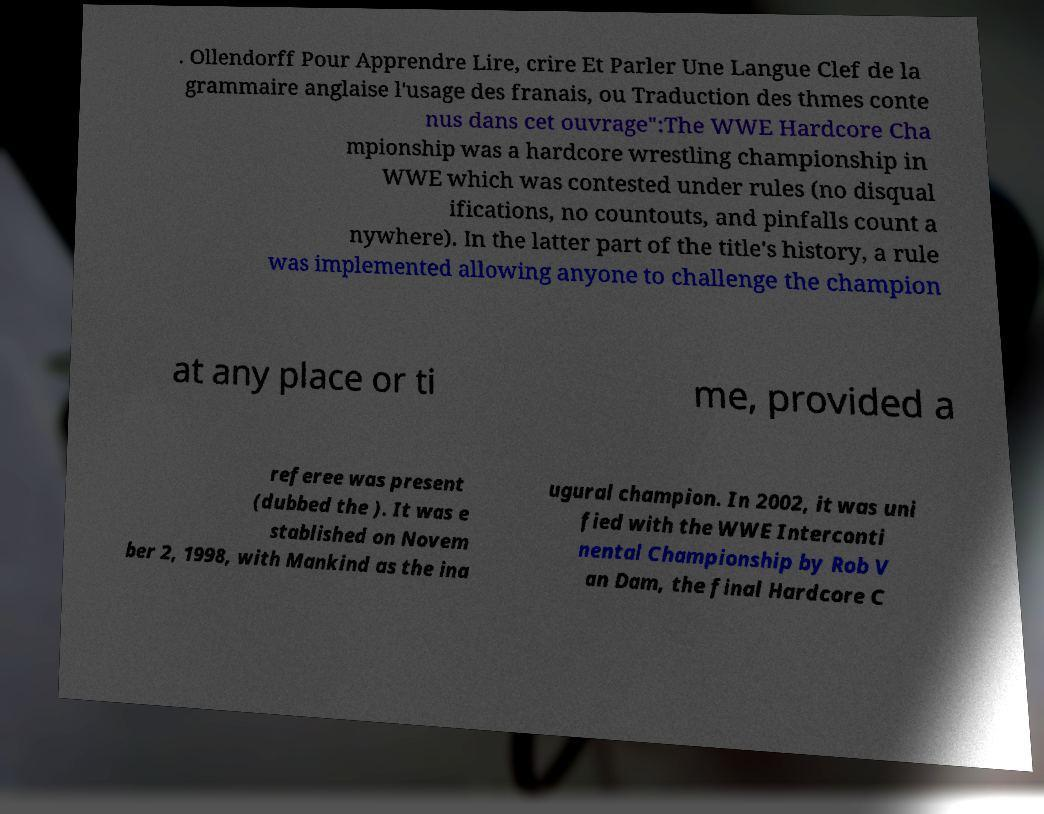Please read and relay the text visible in this image. What does it say? . Ollendorff Pour Apprendre Lire, crire Et Parler Une Langue Clef de la grammaire anglaise l'usage des franais, ou Traduction des thmes conte nus dans cet ouvrage":The WWE Hardcore Cha mpionship was a hardcore wrestling championship in WWE which was contested under rules (no disqual ifications, no countouts, and pinfalls count a nywhere). In the latter part of the title's history, a rule was implemented allowing anyone to challenge the champion at any place or ti me, provided a referee was present (dubbed the ). It was e stablished on Novem ber 2, 1998, with Mankind as the ina ugural champion. In 2002, it was uni fied with the WWE Interconti nental Championship by Rob V an Dam, the final Hardcore C 